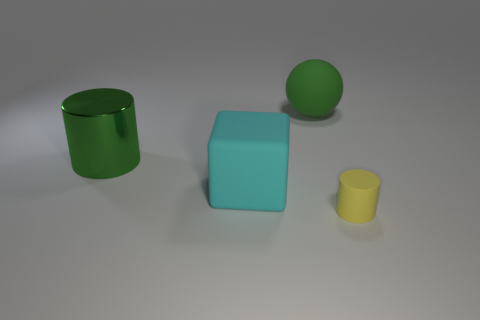Add 1 tiny red rubber cylinders. How many objects exist? 5 Subtract all blocks. How many objects are left? 3 Add 3 large cyan cubes. How many large cyan cubes exist? 4 Subtract 0 purple cylinders. How many objects are left? 4 Subtract all green cubes. Subtract all green objects. How many objects are left? 2 Add 2 matte blocks. How many matte blocks are left? 3 